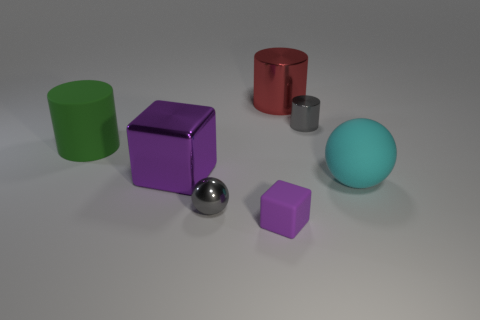What color is the small shiny thing that is behind the purple cube behind the cyan rubber thing that is on the right side of the large metallic cube?
Offer a terse response. Gray. Is there a brown rubber object that has the same shape as the big cyan rubber object?
Provide a succinct answer. No. Are there an equal number of big balls that are on the right side of the big cyan object and tiny gray metal things in front of the small matte object?
Offer a very short reply. Yes. Does the gray object behind the green cylinder have the same shape as the green matte thing?
Your answer should be very brief. Yes. Do the big red object and the large cyan thing have the same shape?
Keep it short and to the point. No. What number of shiny things are either large cyan cylinders or big green cylinders?
Your answer should be very brief. 0. There is a small object that is the same color as the shiny cube; what is its material?
Give a very brief answer. Rubber. Do the purple metal block and the green cylinder have the same size?
Ensure brevity in your answer.  Yes. What number of objects are either cyan balls or metallic things that are to the left of the red cylinder?
Give a very brief answer. 3. There is a cylinder that is the same size as the purple rubber cube; what material is it?
Provide a short and direct response. Metal. 